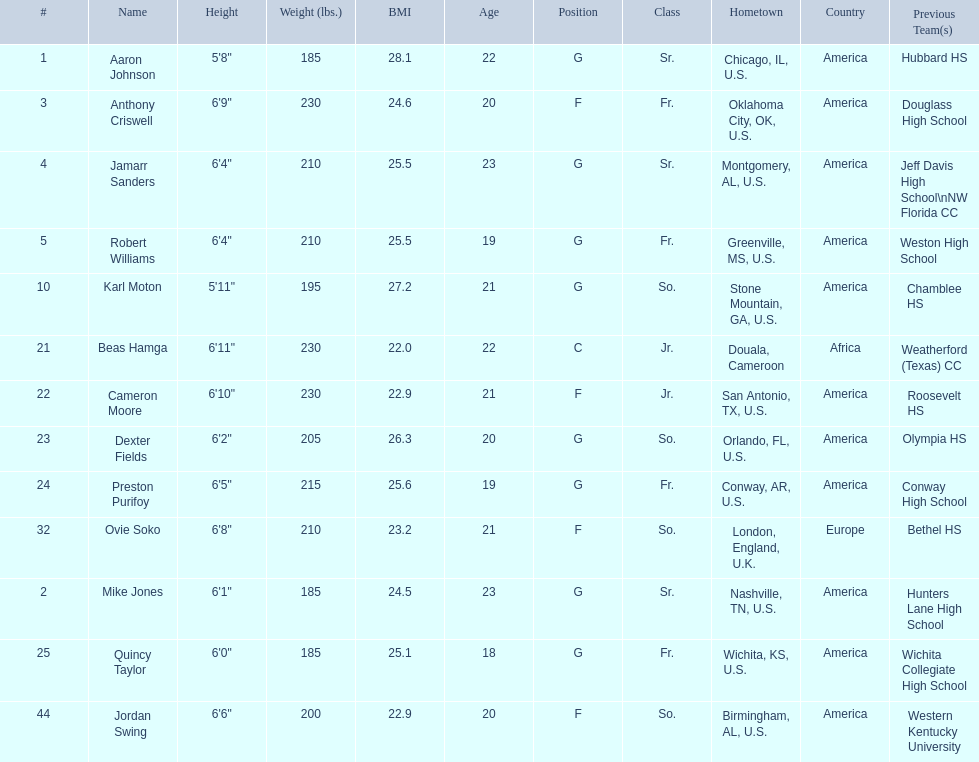Who are all the players? Aaron Johnson, Anthony Criswell, Jamarr Sanders, Robert Williams, Karl Moton, Beas Hamga, Cameron Moore, Dexter Fields, Preston Purifoy, Ovie Soko, Mike Jones, Quincy Taylor, Jordan Swing. Of these, which are not soko? Aaron Johnson, Anthony Criswell, Jamarr Sanders, Robert Williams, Karl Moton, Beas Hamga, Cameron Moore, Dexter Fields, Preston Purifoy, Mike Jones, Quincy Taylor, Jordan Swing. Where are these players from? Sr., Fr., Sr., Fr., So., Jr., Jr., So., Fr., Sr., Fr., So. Would you be able to parse every entry in this table? {'header': ['#', 'Name', 'Height', 'Weight (lbs.)', 'BMI', 'Age', 'Position', 'Class', 'Hometown', 'Country', 'Previous Team(s)'], 'rows': [['1', 'Aaron Johnson', '5\'8"', '185', '28.1', '22', 'G', 'Sr.', 'Chicago, IL, U.S.', 'America', 'Hubbard HS'], ['3', 'Anthony Criswell', '6\'9"', '230', '24.6', '20', 'F', 'Fr.', 'Oklahoma City, OK, U.S.', 'America', 'Douglass High School'], ['4', 'Jamarr Sanders', '6\'4"', '210', '25.5', '23', 'G', 'Sr.', 'Montgomery, AL, U.S.', 'America', 'Jeff Davis High School\\nNW Florida CC'], ['5', 'Robert Williams', '6\'4"', '210', '25.5', '19', 'G', 'Fr.', 'Greenville, MS, U.S.', 'America', 'Weston High School'], ['10', 'Karl Moton', '5\'11"', '195', '27.2', '21', 'G', 'So.', 'Stone Mountain, GA, U.S.', 'America', 'Chamblee HS'], ['21', 'Beas Hamga', '6\'11"', '230', '22.0', '22', 'C', 'Jr.', 'Douala, Cameroon', 'Africa', 'Weatherford (Texas) CC'], ['22', 'Cameron Moore', '6\'10"', '230', '22.9', '21', 'F', 'Jr.', 'San Antonio, TX, U.S.', 'America', 'Roosevelt HS'], ['23', 'Dexter Fields', '6\'2"', '205', '26.3', '20', 'G', 'So.', 'Orlando, FL, U.S.', 'America', 'Olympia HS'], ['24', 'Preston Purifoy', '6\'5"', '215', '25.6', '19', 'G', 'Fr.', 'Conway, AR, U.S.', 'America', 'Conway High School'], ['32', 'Ovie Soko', '6\'8"', '210', '23.2', '21', 'F', 'So.', 'London, England, U.K.', 'Europe', 'Bethel HS'], ['2', 'Mike Jones', '6\'1"', '185', '24.5', '23', 'G', 'Sr.', 'Nashville, TN, U.S.', 'America', 'Hunters Lane High School'], ['25', 'Quincy Taylor', '6\'0"', '185', '25.1', '18', 'G', 'Fr.', 'Wichita, KS, U.S.', 'America', 'Wichita Collegiate High School'], ['44', 'Jordan Swing', '6\'6"', '200', '22.9', '20', 'F', 'So.', 'Birmingham, AL, U.S.', 'America', 'Western Kentucky University']]} Of these locations, which are not in the u.s.? Jr. Which player is from this location? Beas Hamga. 